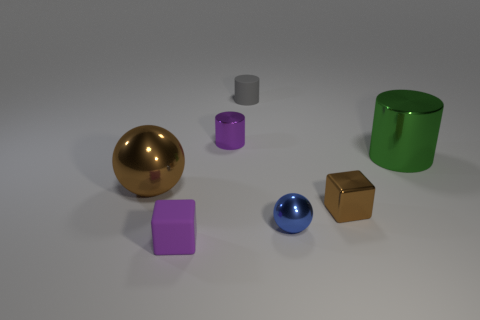Does the metallic cube have the same color as the big shiny ball? yes 